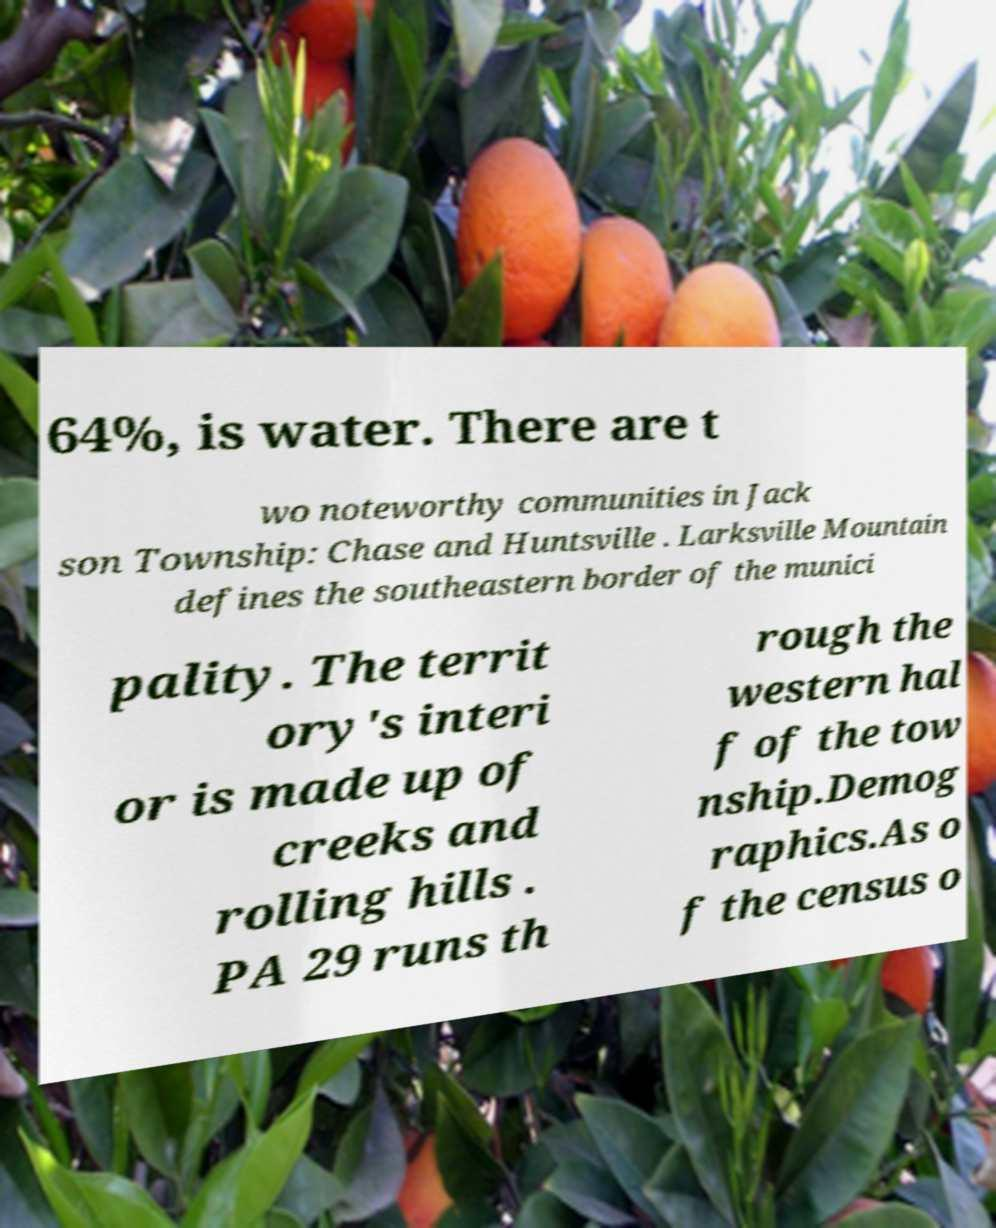What messages or text are displayed in this image? I need them in a readable, typed format. 64%, is water. There are t wo noteworthy communities in Jack son Township: Chase and Huntsville . Larksville Mountain defines the southeastern border of the munici pality. The territ ory's interi or is made up of creeks and rolling hills . PA 29 runs th rough the western hal f of the tow nship.Demog raphics.As o f the census o 